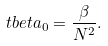<formula> <loc_0><loc_0><loc_500><loc_500>\ t b e t a _ { 0 } = \frac { \beta } { N ^ { 2 } } .</formula> 